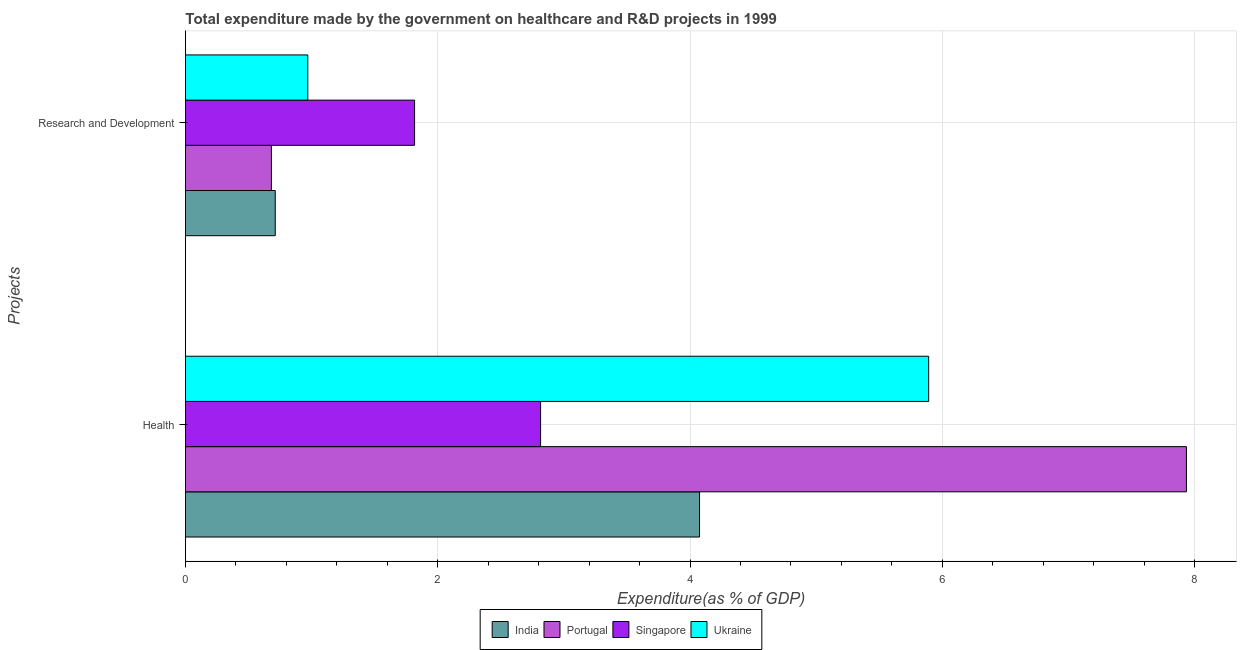How many groups of bars are there?
Keep it short and to the point. 2. Are the number of bars on each tick of the Y-axis equal?
Your answer should be compact. Yes. How many bars are there on the 1st tick from the top?
Your answer should be compact. 4. How many bars are there on the 1st tick from the bottom?
Your answer should be very brief. 4. What is the label of the 2nd group of bars from the top?
Give a very brief answer. Health. What is the expenditure in r&d in Ukraine?
Offer a very short reply. 0.97. Across all countries, what is the maximum expenditure in healthcare?
Your answer should be compact. 7.94. Across all countries, what is the minimum expenditure in r&d?
Offer a very short reply. 0.68. In which country was the expenditure in healthcare maximum?
Your answer should be compact. Portugal. In which country was the expenditure in healthcare minimum?
Ensure brevity in your answer.  Singapore. What is the total expenditure in healthcare in the graph?
Make the answer very short. 20.72. What is the difference between the expenditure in healthcare in Ukraine and that in Singapore?
Your answer should be compact. 3.08. What is the difference between the expenditure in healthcare in Portugal and the expenditure in r&d in India?
Give a very brief answer. 7.22. What is the average expenditure in healthcare per country?
Keep it short and to the point. 5.18. What is the difference between the expenditure in r&d and expenditure in healthcare in Ukraine?
Provide a succinct answer. -4.92. What is the ratio of the expenditure in healthcare in Singapore to that in India?
Provide a succinct answer. 0.69. Is the expenditure in r&d in Portugal less than that in Ukraine?
Provide a short and direct response. Yes. What does the 3rd bar from the bottom in Health represents?
Make the answer very short. Singapore. How many bars are there?
Make the answer very short. 8. Are all the bars in the graph horizontal?
Provide a succinct answer. Yes. How many countries are there in the graph?
Offer a very short reply. 4. What is the difference between two consecutive major ticks on the X-axis?
Provide a succinct answer. 2. Does the graph contain any zero values?
Your answer should be compact. No. Does the graph contain grids?
Ensure brevity in your answer.  Yes. Where does the legend appear in the graph?
Offer a very short reply. Bottom center. How many legend labels are there?
Provide a succinct answer. 4. What is the title of the graph?
Your response must be concise. Total expenditure made by the government on healthcare and R&D projects in 1999. Does "Philippines" appear as one of the legend labels in the graph?
Your answer should be compact. No. What is the label or title of the X-axis?
Your answer should be compact. Expenditure(as % of GDP). What is the label or title of the Y-axis?
Give a very brief answer. Projects. What is the Expenditure(as % of GDP) of India in Health?
Make the answer very short. 4.08. What is the Expenditure(as % of GDP) of Portugal in Health?
Provide a succinct answer. 7.94. What is the Expenditure(as % of GDP) in Singapore in Health?
Your answer should be very brief. 2.82. What is the Expenditure(as % of GDP) in Ukraine in Health?
Ensure brevity in your answer.  5.89. What is the Expenditure(as % of GDP) of India in Research and Development?
Give a very brief answer. 0.71. What is the Expenditure(as % of GDP) of Portugal in Research and Development?
Your response must be concise. 0.68. What is the Expenditure(as % of GDP) of Singapore in Research and Development?
Your answer should be very brief. 1.82. What is the Expenditure(as % of GDP) of Ukraine in Research and Development?
Make the answer very short. 0.97. Across all Projects, what is the maximum Expenditure(as % of GDP) in India?
Make the answer very short. 4.08. Across all Projects, what is the maximum Expenditure(as % of GDP) of Portugal?
Ensure brevity in your answer.  7.94. Across all Projects, what is the maximum Expenditure(as % of GDP) in Singapore?
Offer a very short reply. 2.82. Across all Projects, what is the maximum Expenditure(as % of GDP) of Ukraine?
Provide a short and direct response. 5.89. Across all Projects, what is the minimum Expenditure(as % of GDP) of India?
Make the answer very short. 0.71. Across all Projects, what is the minimum Expenditure(as % of GDP) in Portugal?
Your answer should be compact. 0.68. Across all Projects, what is the minimum Expenditure(as % of GDP) of Singapore?
Ensure brevity in your answer.  1.82. Across all Projects, what is the minimum Expenditure(as % of GDP) of Ukraine?
Your response must be concise. 0.97. What is the total Expenditure(as % of GDP) in India in the graph?
Offer a terse response. 4.79. What is the total Expenditure(as % of GDP) of Portugal in the graph?
Your answer should be compact. 8.62. What is the total Expenditure(as % of GDP) in Singapore in the graph?
Offer a very short reply. 4.63. What is the total Expenditure(as % of GDP) in Ukraine in the graph?
Keep it short and to the point. 6.86. What is the difference between the Expenditure(as % of GDP) of India in Health and that in Research and Development?
Your answer should be compact. 3.36. What is the difference between the Expenditure(as % of GDP) in Portugal in Health and that in Research and Development?
Make the answer very short. 7.25. What is the difference between the Expenditure(as % of GDP) of Singapore in Health and that in Research and Development?
Your response must be concise. 1. What is the difference between the Expenditure(as % of GDP) in Ukraine in Health and that in Research and Development?
Offer a terse response. 4.92. What is the difference between the Expenditure(as % of GDP) of India in Health and the Expenditure(as % of GDP) of Portugal in Research and Development?
Your answer should be compact. 3.39. What is the difference between the Expenditure(as % of GDP) in India in Health and the Expenditure(as % of GDP) in Singapore in Research and Development?
Your response must be concise. 2.26. What is the difference between the Expenditure(as % of GDP) of India in Health and the Expenditure(as % of GDP) of Ukraine in Research and Development?
Ensure brevity in your answer.  3.11. What is the difference between the Expenditure(as % of GDP) in Portugal in Health and the Expenditure(as % of GDP) in Singapore in Research and Development?
Your answer should be very brief. 6.12. What is the difference between the Expenditure(as % of GDP) of Portugal in Health and the Expenditure(as % of GDP) of Ukraine in Research and Development?
Make the answer very short. 6.97. What is the difference between the Expenditure(as % of GDP) in Singapore in Health and the Expenditure(as % of GDP) in Ukraine in Research and Development?
Make the answer very short. 1.85. What is the average Expenditure(as % of GDP) of India per Projects?
Ensure brevity in your answer.  2.39. What is the average Expenditure(as % of GDP) of Portugal per Projects?
Offer a very short reply. 4.31. What is the average Expenditure(as % of GDP) of Singapore per Projects?
Offer a very short reply. 2.32. What is the average Expenditure(as % of GDP) of Ukraine per Projects?
Ensure brevity in your answer.  3.43. What is the difference between the Expenditure(as % of GDP) in India and Expenditure(as % of GDP) in Portugal in Health?
Your answer should be very brief. -3.86. What is the difference between the Expenditure(as % of GDP) in India and Expenditure(as % of GDP) in Singapore in Health?
Provide a succinct answer. 1.26. What is the difference between the Expenditure(as % of GDP) in India and Expenditure(as % of GDP) in Ukraine in Health?
Provide a short and direct response. -1.82. What is the difference between the Expenditure(as % of GDP) in Portugal and Expenditure(as % of GDP) in Singapore in Health?
Give a very brief answer. 5.12. What is the difference between the Expenditure(as % of GDP) of Portugal and Expenditure(as % of GDP) of Ukraine in Health?
Make the answer very short. 2.04. What is the difference between the Expenditure(as % of GDP) in Singapore and Expenditure(as % of GDP) in Ukraine in Health?
Your response must be concise. -3.08. What is the difference between the Expenditure(as % of GDP) in India and Expenditure(as % of GDP) in Portugal in Research and Development?
Ensure brevity in your answer.  0.03. What is the difference between the Expenditure(as % of GDP) in India and Expenditure(as % of GDP) in Singapore in Research and Development?
Offer a very short reply. -1.1. What is the difference between the Expenditure(as % of GDP) of India and Expenditure(as % of GDP) of Ukraine in Research and Development?
Offer a very short reply. -0.26. What is the difference between the Expenditure(as % of GDP) in Portugal and Expenditure(as % of GDP) in Singapore in Research and Development?
Make the answer very short. -1.14. What is the difference between the Expenditure(as % of GDP) of Portugal and Expenditure(as % of GDP) of Ukraine in Research and Development?
Your answer should be very brief. -0.29. What is the difference between the Expenditure(as % of GDP) of Singapore and Expenditure(as % of GDP) of Ukraine in Research and Development?
Keep it short and to the point. 0.85. What is the ratio of the Expenditure(as % of GDP) of India in Health to that in Research and Development?
Your response must be concise. 5.73. What is the ratio of the Expenditure(as % of GDP) in Portugal in Health to that in Research and Development?
Offer a terse response. 11.65. What is the ratio of the Expenditure(as % of GDP) of Singapore in Health to that in Research and Development?
Your response must be concise. 1.55. What is the ratio of the Expenditure(as % of GDP) in Ukraine in Health to that in Research and Development?
Offer a very short reply. 6.08. What is the difference between the highest and the second highest Expenditure(as % of GDP) of India?
Your answer should be compact. 3.36. What is the difference between the highest and the second highest Expenditure(as % of GDP) in Portugal?
Ensure brevity in your answer.  7.25. What is the difference between the highest and the second highest Expenditure(as % of GDP) of Singapore?
Offer a very short reply. 1. What is the difference between the highest and the second highest Expenditure(as % of GDP) of Ukraine?
Provide a succinct answer. 4.92. What is the difference between the highest and the lowest Expenditure(as % of GDP) of India?
Offer a very short reply. 3.36. What is the difference between the highest and the lowest Expenditure(as % of GDP) of Portugal?
Make the answer very short. 7.25. What is the difference between the highest and the lowest Expenditure(as % of GDP) in Singapore?
Offer a very short reply. 1. What is the difference between the highest and the lowest Expenditure(as % of GDP) of Ukraine?
Your answer should be compact. 4.92. 